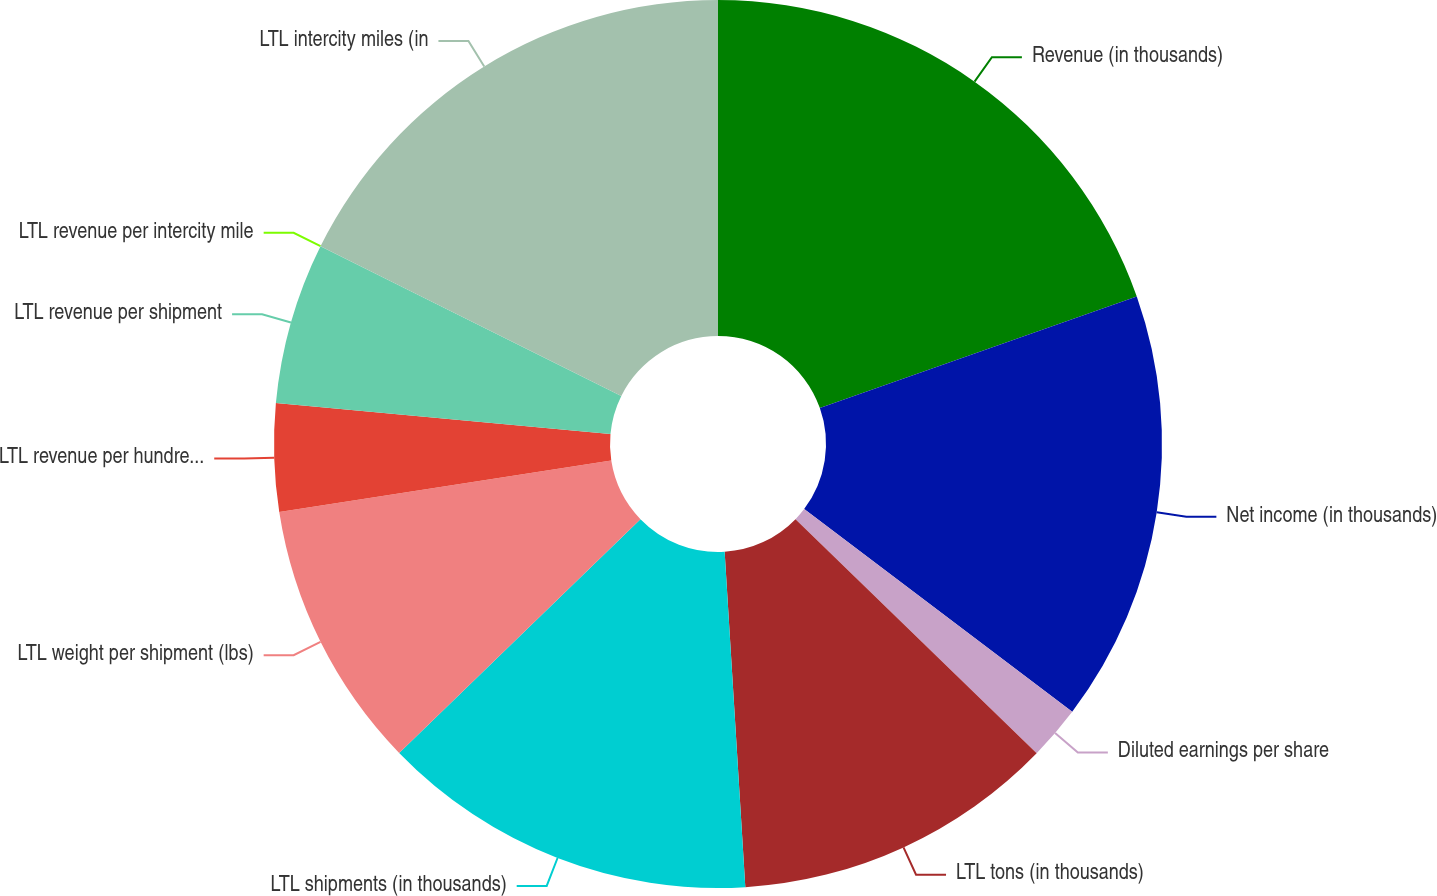Convert chart to OTSL. <chart><loc_0><loc_0><loc_500><loc_500><pie_chart><fcel>Revenue (in thousands)<fcel>Net income (in thousands)<fcel>Diluted earnings per share<fcel>LTL tons (in thousands)<fcel>LTL shipments (in thousands)<fcel>LTL weight per shipment (lbs)<fcel>LTL revenue per hundredweight<fcel>LTL revenue per shipment<fcel>LTL revenue per intercity mile<fcel>LTL intercity miles (in<nl><fcel>19.61%<fcel>15.69%<fcel>1.96%<fcel>11.76%<fcel>13.73%<fcel>9.8%<fcel>3.92%<fcel>5.88%<fcel>0.0%<fcel>17.65%<nl></chart> 